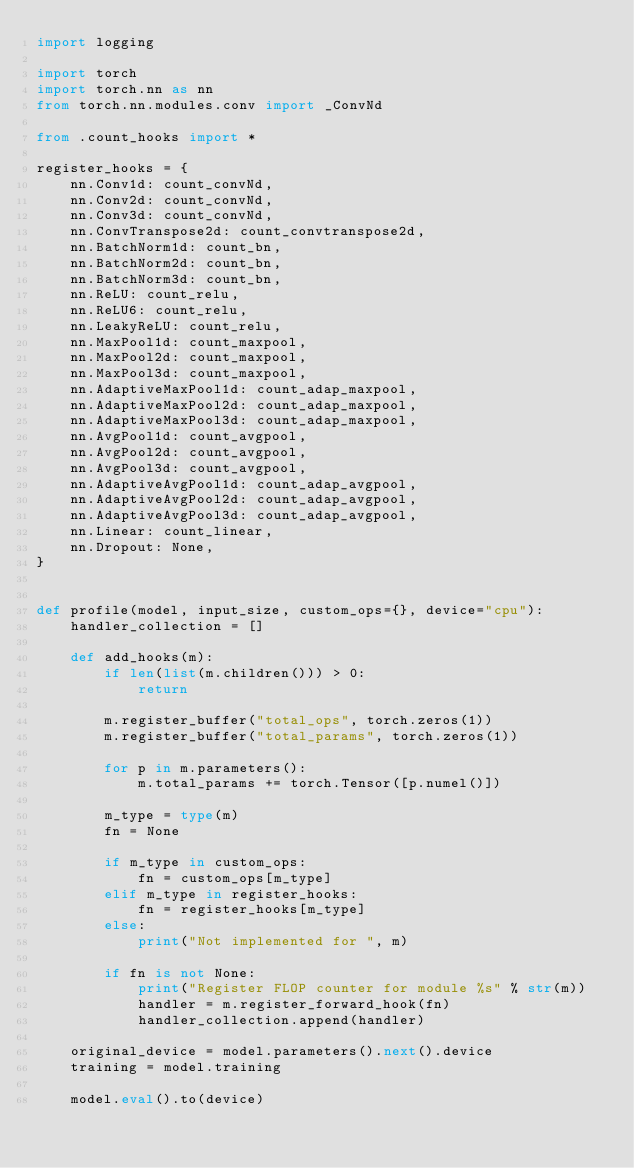Convert code to text. <code><loc_0><loc_0><loc_500><loc_500><_Python_>import logging

import torch
import torch.nn as nn
from torch.nn.modules.conv import _ConvNd

from .count_hooks import *

register_hooks = {
    nn.Conv1d: count_convNd,
    nn.Conv2d: count_convNd,
    nn.Conv3d: count_convNd,
    nn.ConvTranspose2d: count_convtranspose2d,
    nn.BatchNorm1d: count_bn,
    nn.BatchNorm2d: count_bn,
    nn.BatchNorm3d: count_bn,
    nn.ReLU: count_relu,
    nn.ReLU6: count_relu,
    nn.LeakyReLU: count_relu,
    nn.MaxPool1d: count_maxpool,
    nn.MaxPool2d: count_maxpool,
    nn.MaxPool3d: count_maxpool,
    nn.AdaptiveMaxPool1d: count_adap_maxpool,
    nn.AdaptiveMaxPool2d: count_adap_maxpool,
    nn.AdaptiveMaxPool3d: count_adap_maxpool,
    nn.AvgPool1d: count_avgpool,
    nn.AvgPool2d: count_avgpool,
    nn.AvgPool3d: count_avgpool,
    nn.AdaptiveAvgPool1d: count_adap_avgpool,
    nn.AdaptiveAvgPool2d: count_adap_avgpool,
    nn.AdaptiveAvgPool3d: count_adap_avgpool,
    nn.Linear: count_linear,
    nn.Dropout: None,
}


def profile(model, input_size, custom_ops={}, device="cpu"):
    handler_collection = []

    def add_hooks(m):
        if len(list(m.children())) > 0:
            return

        m.register_buffer("total_ops", torch.zeros(1))
        m.register_buffer("total_params", torch.zeros(1))

        for p in m.parameters():
            m.total_params += torch.Tensor([p.numel()])

        m_type = type(m)
        fn = None

        if m_type in custom_ops:
            fn = custom_ops[m_type]
        elif m_type in register_hooks:
            fn = register_hooks[m_type]
        else:
            print("Not implemented for ", m)

        if fn is not None:
            print("Register FLOP counter for module %s" % str(m))
            handler = m.register_forward_hook(fn)
            handler_collection.append(handler)

    original_device = model.parameters().next().device
    training = model.training

    model.eval().to(device)</code> 